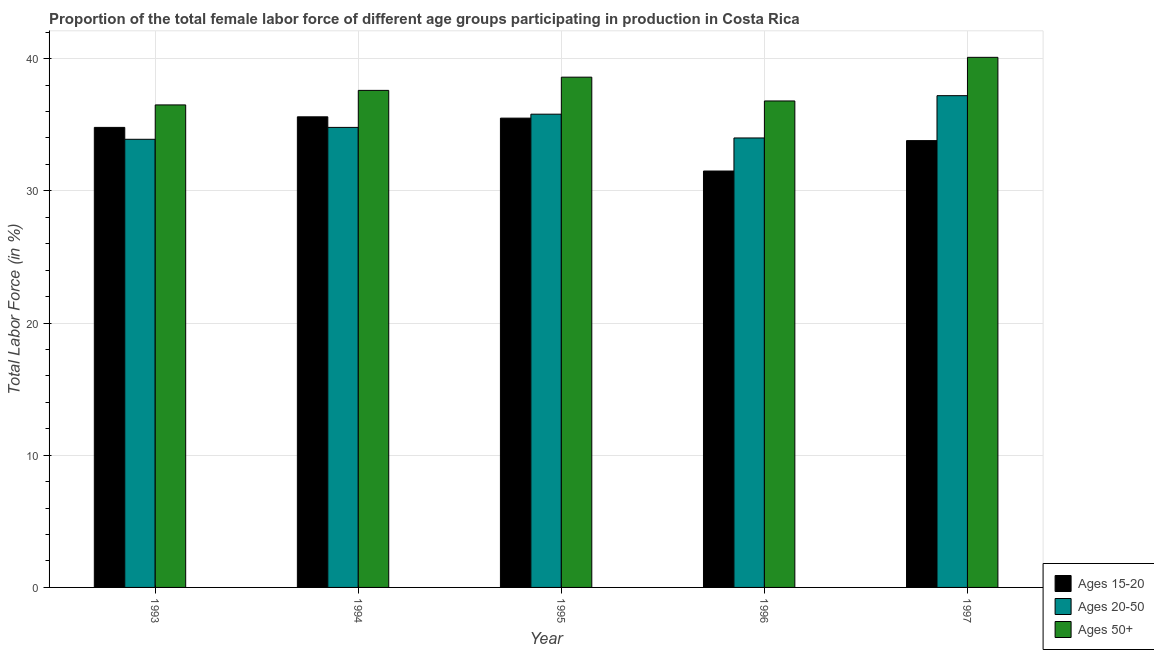How many groups of bars are there?
Make the answer very short. 5. Are the number of bars on each tick of the X-axis equal?
Make the answer very short. Yes. How many bars are there on the 3rd tick from the left?
Provide a short and direct response. 3. What is the label of the 2nd group of bars from the left?
Keep it short and to the point. 1994. What is the percentage of female labor force within the age group 20-50 in 1995?
Offer a very short reply. 35.8. Across all years, what is the maximum percentage of female labor force above age 50?
Your answer should be very brief. 40.1. Across all years, what is the minimum percentage of female labor force above age 50?
Offer a very short reply. 36.5. In which year was the percentage of female labor force within the age group 15-20 maximum?
Your answer should be compact. 1994. In which year was the percentage of female labor force within the age group 20-50 minimum?
Give a very brief answer. 1993. What is the total percentage of female labor force within the age group 15-20 in the graph?
Offer a very short reply. 171.2. What is the difference between the percentage of female labor force within the age group 20-50 in 1995 and that in 1996?
Give a very brief answer. 1.8. What is the difference between the percentage of female labor force within the age group 20-50 in 1996 and the percentage of female labor force within the age group 15-20 in 1997?
Give a very brief answer. -3.2. What is the average percentage of female labor force above age 50 per year?
Your response must be concise. 37.92. In how many years, is the percentage of female labor force above age 50 greater than 32 %?
Give a very brief answer. 5. What is the ratio of the percentage of female labor force within the age group 15-20 in 1993 to that in 1996?
Provide a succinct answer. 1.1. Is the percentage of female labor force within the age group 15-20 in 1994 less than that in 1996?
Make the answer very short. No. Is the difference between the percentage of female labor force above age 50 in 1995 and 1996 greater than the difference between the percentage of female labor force within the age group 15-20 in 1995 and 1996?
Ensure brevity in your answer.  No. What is the difference between the highest and the second highest percentage of female labor force within the age group 15-20?
Your answer should be very brief. 0.1. What is the difference between the highest and the lowest percentage of female labor force above age 50?
Your response must be concise. 3.6. Is the sum of the percentage of female labor force within the age group 15-20 in 1994 and 1996 greater than the maximum percentage of female labor force within the age group 20-50 across all years?
Your answer should be very brief. Yes. What does the 3rd bar from the left in 1994 represents?
Keep it short and to the point. Ages 50+. What does the 1st bar from the right in 1995 represents?
Give a very brief answer. Ages 50+. Is it the case that in every year, the sum of the percentage of female labor force within the age group 15-20 and percentage of female labor force within the age group 20-50 is greater than the percentage of female labor force above age 50?
Give a very brief answer. Yes. How many bars are there?
Provide a short and direct response. 15. Are all the bars in the graph horizontal?
Your response must be concise. No. Does the graph contain any zero values?
Offer a very short reply. No. How are the legend labels stacked?
Provide a succinct answer. Vertical. What is the title of the graph?
Offer a very short reply. Proportion of the total female labor force of different age groups participating in production in Costa Rica. What is the label or title of the Y-axis?
Your response must be concise. Total Labor Force (in %). What is the Total Labor Force (in %) of Ages 15-20 in 1993?
Provide a short and direct response. 34.8. What is the Total Labor Force (in %) in Ages 20-50 in 1993?
Ensure brevity in your answer.  33.9. What is the Total Labor Force (in %) of Ages 50+ in 1993?
Offer a very short reply. 36.5. What is the Total Labor Force (in %) in Ages 15-20 in 1994?
Give a very brief answer. 35.6. What is the Total Labor Force (in %) of Ages 20-50 in 1994?
Make the answer very short. 34.8. What is the Total Labor Force (in %) in Ages 50+ in 1994?
Your answer should be very brief. 37.6. What is the Total Labor Force (in %) in Ages 15-20 in 1995?
Keep it short and to the point. 35.5. What is the Total Labor Force (in %) of Ages 20-50 in 1995?
Make the answer very short. 35.8. What is the Total Labor Force (in %) of Ages 50+ in 1995?
Provide a succinct answer. 38.6. What is the Total Labor Force (in %) of Ages 15-20 in 1996?
Provide a succinct answer. 31.5. What is the Total Labor Force (in %) of Ages 50+ in 1996?
Provide a short and direct response. 36.8. What is the Total Labor Force (in %) in Ages 15-20 in 1997?
Your response must be concise. 33.8. What is the Total Labor Force (in %) in Ages 20-50 in 1997?
Your answer should be compact. 37.2. What is the Total Labor Force (in %) of Ages 50+ in 1997?
Keep it short and to the point. 40.1. Across all years, what is the maximum Total Labor Force (in %) in Ages 15-20?
Your answer should be compact. 35.6. Across all years, what is the maximum Total Labor Force (in %) in Ages 20-50?
Make the answer very short. 37.2. Across all years, what is the maximum Total Labor Force (in %) in Ages 50+?
Keep it short and to the point. 40.1. Across all years, what is the minimum Total Labor Force (in %) of Ages 15-20?
Offer a terse response. 31.5. Across all years, what is the minimum Total Labor Force (in %) of Ages 20-50?
Keep it short and to the point. 33.9. Across all years, what is the minimum Total Labor Force (in %) in Ages 50+?
Your answer should be compact. 36.5. What is the total Total Labor Force (in %) in Ages 15-20 in the graph?
Provide a succinct answer. 171.2. What is the total Total Labor Force (in %) of Ages 20-50 in the graph?
Offer a very short reply. 175.7. What is the total Total Labor Force (in %) in Ages 50+ in the graph?
Provide a short and direct response. 189.6. What is the difference between the Total Labor Force (in %) of Ages 15-20 in 1993 and that in 1994?
Provide a succinct answer. -0.8. What is the difference between the Total Labor Force (in %) in Ages 50+ in 1993 and that in 1994?
Keep it short and to the point. -1.1. What is the difference between the Total Labor Force (in %) of Ages 15-20 in 1993 and that in 1995?
Offer a terse response. -0.7. What is the difference between the Total Labor Force (in %) in Ages 15-20 in 1993 and that in 1996?
Offer a terse response. 3.3. What is the difference between the Total Labor Force (in %) of Ages 20-50 in 1993 and that in 1996?
Keep it short and to the point. -0.1. What is the difference between the Total Labor Force (in %) of Ages 50+ in 1993 and that in 1996?
Offer a terse response. -0.3. What is the difference between the Total Labor Force (in %) in Ages 50+ in 1993 and that in 1997?
Your answer should be compact. -3.6. What is the difference between the Total Labor Force (in %) in Ages 15-20 in 1994 and that in 1995?
Your answer should be compact. 0.1. What is the difference between the Total Labor Force (in %) of Ages 50+ in 1994 and that in 1995?
Provide a succinct answer. -1. What is the difference between the Total Labor Force (in %) in Ages 15-20 in 1994 and that in 1996?
Your answer should be very brief. 4.1. What is the difference between the Total Labor Force (in %) in Ages 20-50 in 1994 and that in 1996?
Offer a terse response. 0.8. What is the difference between the Total Labor Force (in %) of Ages 50+ in 1994 and that in 1996?
Provide a succinct answer. 0.8. What is the difference between the Total Labor Force (in %) of Ages 20-50 in 1994 and that in 1997?
Provide a succinct answer. -2.4. What is the difference between the Total Labor Force (in %) in Ages 15-20 in 1995 and that in 1996?
Offer a terse response. 4. What is the difference between the Total Labor Force (in %) in Ages 20-50 in 1995 and that in 1996?
Make the answer very short. 1.8. What is the difference between the Total Labor Force (in %) in Ages 50+ in 1995 and that in 1996?
Your response must be concise. 1.8. What is the difference between the Total Labor Force (in %) in Ages 15-20 in 1995 and that in 1997?
Your answer should be very brief. 1.7. What is the difference between the Total Labor Force (in %) in Ages 20-50 in 1996 and that in 1997?
Make the answer very short. -3.2. What is the difference between the Total Labor Force (in %) of Ages 15-20 in 1993 and the Total Labor Force (in %) of Ages 20-50 in 1994?
Provide a succinct answer. 0. What is the difference between the Total Labor Force (in %) of Ages 20-50 in 1993 and the Total Labor Force (in %) of Ages 50+ in 1994?
Your answer should be very brief. -3.7. What is the difference between the Total Labor Force (in %) in Ages 20-50 in 1993 and the Total Labor Force (in %) in Ages 50+ in 1996?
Make the answer very short. -2.9. What is the difference between the Total Labor Force (in %) of Ages 15-20 in 1993 and the Total Labor Force (in %) of Ages 20-50 in 1997?
Your answer should be compact. -2.4. What is the difference between the Total Labor Force (in %) of Ages 15-20 in 1993 and the Total Labor Force (in %) of Ages 50+ in 1997?
Make the answer very short. -5.3. What is the difference between the Total Labor Force (in %) of Ages 15-20 in 1994 and the Total Labor Force (in %) of Ages 50+ in 1995?
Your response must be concise. -3. What is the difference between the Total Labor Force (in %) of Ages 15-20 in 1994 and the Total Labor Force (in %) of Ages 50+ in 1996?
Keep it short and to the point. -1.2. What is the difference between the Total Labor Force (in %) in Ages 20-50 in 1994 and the Total Labor Force (in %) in Ages 50+ in 1996?
Give a very brief answer. -2. What is the difference between the Total Labor Force (in %) of Ages 15-20 in 1995 and the Total Labor Force (in %) of Ages 50+ in 1996?
Make the answer very short. -1.3. What is the difference between the Total Labor Force (in %) in Ages 15-20 in 1995 and the Total Labor Force (in %) in Ages 20-50 in 1997?
Give a very brief answer. -1.7. What is the difference between the Total Labor Force (in %) in Ages 15-20 in 1996 and the Total Labor Force (in %) in Ages 50+ in 1997?
Give a very brief answer. -8.6. What is the difference between the Total Labor Force (in %) of Ages 20-50 in 1996 and the Total Labor Force (in %) of Ages 50+ in 1997?
Offer a terse response. -6.1. What is the average Total Labor Force (in %) of Ages 15-20 per year?
Your answer should be compact. 34.24. What is the average Total Labor Force (in %) of Ages 20-50 per year?
Your response must be concise. 35.14. What is the average Total Labor Force (in %) in Ages 50+ per year?
Make the answer very short. 37.92. In the year 1994, what is the difference between the Total Labor Force (in %) in Ages 15-20 and Total Labor Force (in %) in Ages 50+?
Ensure brevity in your answer.  -2. In the year 1994, what is the difference between the Total Labor Force (in %) of Ages 20-50 and Total Labor Force (in %) of Ages 50+?
Keep it short and to the point. -2.8. In the year 1995, what is the difference between the Total Labor Force (in %) in Ages 15-20 and Total Labor Force (in %) in Ages 20-50?
Make the answer very short. -0.3. In the year 1995, what is the difference between the Total Labor Force (in %) in Ages 15-20 and Total Labor Force (in %) in Ages 50+?
Your answer should be very brief. -3.1. In the year 1995, what is the difference between the Total Labor Force (in %) in Ages 20-50 and Total Labor Force (in %) in Ages 50+?
Keep it short and to the point. -2.8. In the year 1996, what is the difference between the Total Labor Force (in %) in Ages 15-20 and Total Labor Force (in %) in Ages 20-50?
Offer a terse response. -2.5. In the year 1996, what is the difference between the Total Labor Force (in %) in Ages 15-20 and Total Labor Force (in %) in Ages 50+?
Offer a terse response. -5.3. In the year 1997, what is the difference between the Total Labor Force (in %) in Ages 15-20 and Total Labor Force (in %) in Ages 20-50?
Your response must be concise. -3.4. What is the ratio of the Total Labor Force (in %) in Ages 15-20 in 1993 to that in 1994?
Your answer should be very brief. 0.98. What is the ratio of the Total Labor Force (in %) of Ages 20-50 in 1993 to that in 1994?
Ensure brevity in your answer.  0.97. What is the ratio of the Total Labor Force (in %) of Ages 50+ in 1993 to that in 1994?
Provide a succinct answer. 0.97. What is the ratio of the Total Labor Force (in %) of Ages 15-20 in 1993 to that in 1995?
Make the answer very short. 0.98. What is the ratio of the Total Labor Force (in %) in Ages 20-50 in 1993 to that in 1995?
Keep it short and to the point. 0.95. What is the ratio of the Total Labor Force (in %) of Ages 50+ in 1993 to that in 1995?
Your answer should be very brief. 0.95. What is the ratio of the Total Labor Force (in %) in Ages 15-20 in 1993 to that in 1996?
Provide a short and direct response. 1.1. What is the ratio of the Total Labor Force (in %) of Ages 20-50 in 1993 to that in 1996?
Give a very brief answer. 1. What is the ratio of the Total Labor Force (in %) in Ages 50+ in 1993 to that in 1996?
Offer a terse response. 0.99. What is the ratio of the Total Labor Force (in %) in Ages 15-20 in 1993 to that in 1997?
Offer a very short reply. 1.03. What is the ratio of the Total Labor Force (in %) of Ages 20-50 in 1993 to that in 1997?
Offer a very short reply. 0.91. What is the ratio of the Total Labor Force (in %) in Ages 50+ in 1993 to that in 1997?
Your response must be concise. 0.91. What is the ratio of the Total Labor Force (in %) in Ages 15-20 in 1994 to that in 1995?
Make the answer very short. 1. What is the ratio of the Total Labor Force (in %) in Ages 20-50 in 1994 to that in 1995?
Your answer should be compact. 0.97. What is the ratio of the Total Labor Force (in %) of Ages 50+ in 1994 to that in 1995?
Your response must be concise. 0.97. What is the ratio of the Total Labor Force (in %) in Ages 15-20 in 1994 to that in 1996?
Provide a succinct answer. 1.13. What is the ratio of the Total Labor Force (in %) of Ages 20-50 in 1994 to that in 1996?
Your response must be concise. 1.02. What is the ratio of the Total Labor Force (in %) of Ages 50+ in 1994 to that in 1996?
Offer a very short reply. 1.02. What is the ratio of the Total Labor Force (in %) in Ages 15-20 in 1994 to that in 1997?
Ensure brevity in your answer.  1.05. What is the ratio of the Total Labor Force (in %) of Ages 20-50 in 1994 to that in 1997?
Keep it short and to the point. 0.94. What is the ratio of the Total Labor Force (in %) in Ages 50+ in 1994 to that in 1997?
Offer a very short reply. 0.94. What is the ratio of the Total Labor Force (in %) of Ages 15-20 in 1995 to that in 1996?
Offer a terse response. 1.13. What is the ratio of the Total Labor Force (in %) in Ages 20-50 in 1995 to that in 1996?
Provide a short and direct response. 1.05. What is the ratio of the Total Labor Force (in %) of Ages 50+ in 1995 to that in 1996?
Ensure brevity in your answer.  1.05. What is the ratio of the Total Labor Force (in %) in Ages 15-20 in 1995 to that in 1997?
Provide a short and direct response. 1.05. What is the ratio of the Total Labor Force (in %) in Ages 20-50 in 1995 to that in 1997?
Keep it short and to the point. 0.96. What is the ratio of the Total Labor Force (in %) in Ages 50+ in 1995 to that in 1997?
Your response must be concise. 0.96. What is the ratio of the Total Labor Force (in %) of Ages 15-20 in 1996 to that in 1997?
Your answer should be compact. 0.93. What is the ratio of the Total Labor Force (in %) of Ages 20-50 in 1996 to that in 1997?
Give a very brief answer. 0.91. What is the ratio of the Total Labor Force (in %) in Ages 50+ in 1996 to that in 1997?
Your answer should be very brief. 0.92. What is the difference between the highest and the second highest Total Labor Force (in %) of Ages 20-50?
Your answer should be very brief. 1.4. What is the difference between the highest and the second highest Total Labor Force (in %) of Ages 50+?
Provide a succinct answer. 1.5. What is the difference between the highest and the lowest Total Labor Force (in %) of Ages 15-20?
Your response must be concise. 4.1. What is the difference between the highest and the lowest Total Labor Force (in %) of Ages 50+?
Provide a short and direct response. 3.6. 